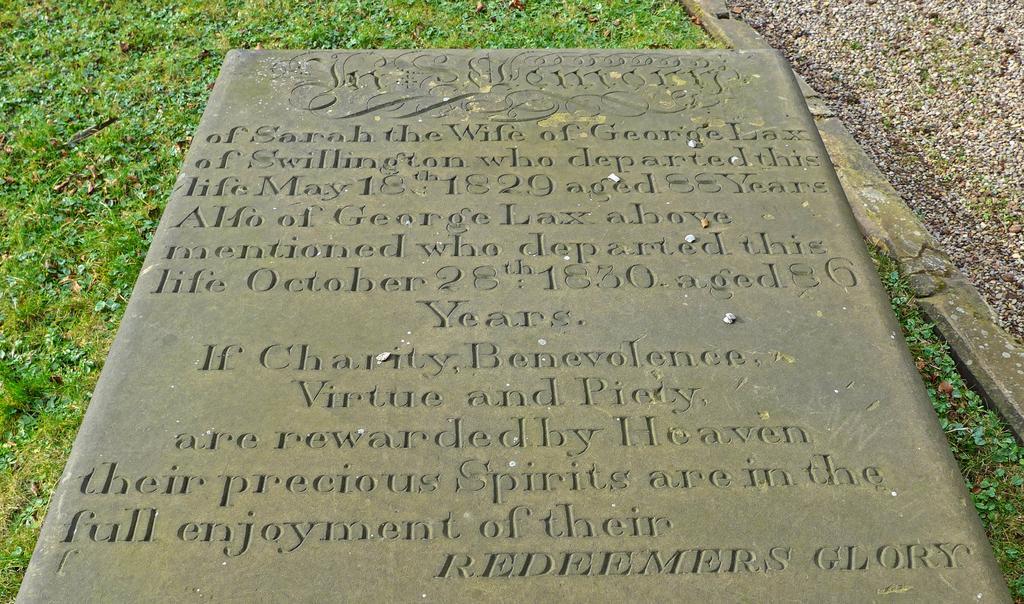How would you summarize this image in a sentence or two? In this image I can see the memorial with some text on it. In the background, I can see the grass. 